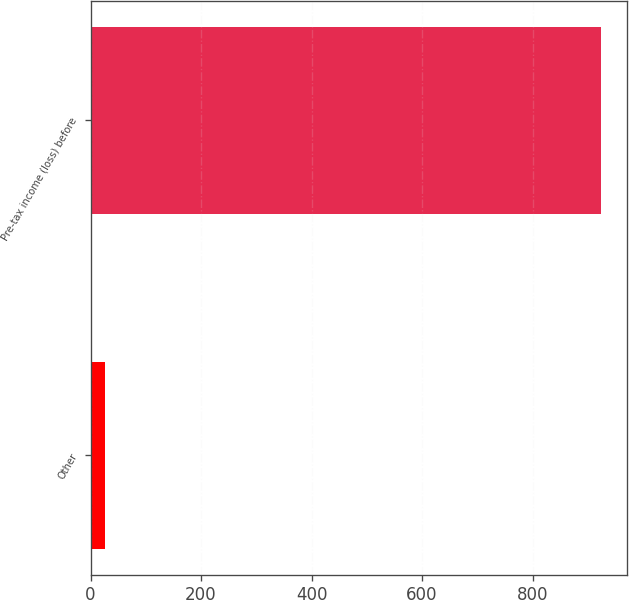Convert chart to OTSL. <chart><loc_0><loc_0><loc_500><loc_500><bar_chart><fcel>Other<fcel>Pre-tax income (loss) before<nl><fcel>26<fcel>924<nl></chart> 